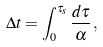<formula> <loc_0><loc_0><loc_500><loc_500>\Delta t = \int _ { 0 } ^ { \tau _ { s } } \frac { d \tau } { \alpha } \, ,</formula> 